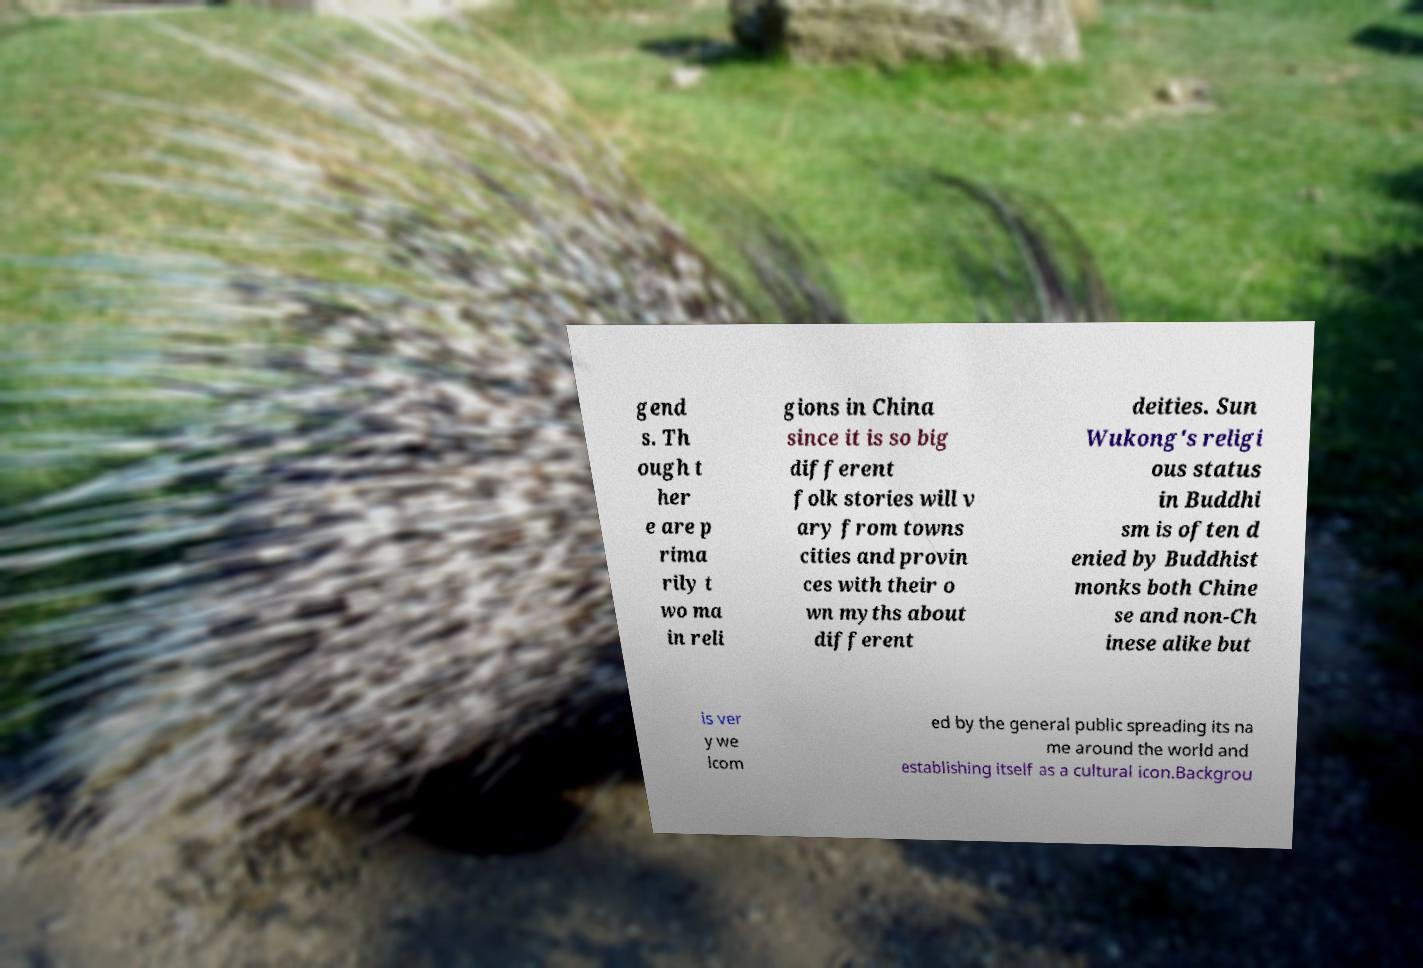Can you read and provide the text displayed in the image?This photo seems to have some interesting text. Can you extract and type it out for me? gend s. Th ough t her e are p rima rily t wo ma in reli gions in China since it is so big different folk stories will v ary from towns cities and provin ces with their o wn myths about different deities. Sun Wukong's religi ous status in Buddhi sm is often d enied by Buddhist monks both Chine se and non-Ch inese alike but is ver y we lcom ed by the general public spreading its na me around the world and establishing itself as a cultural icon.Backgrou 